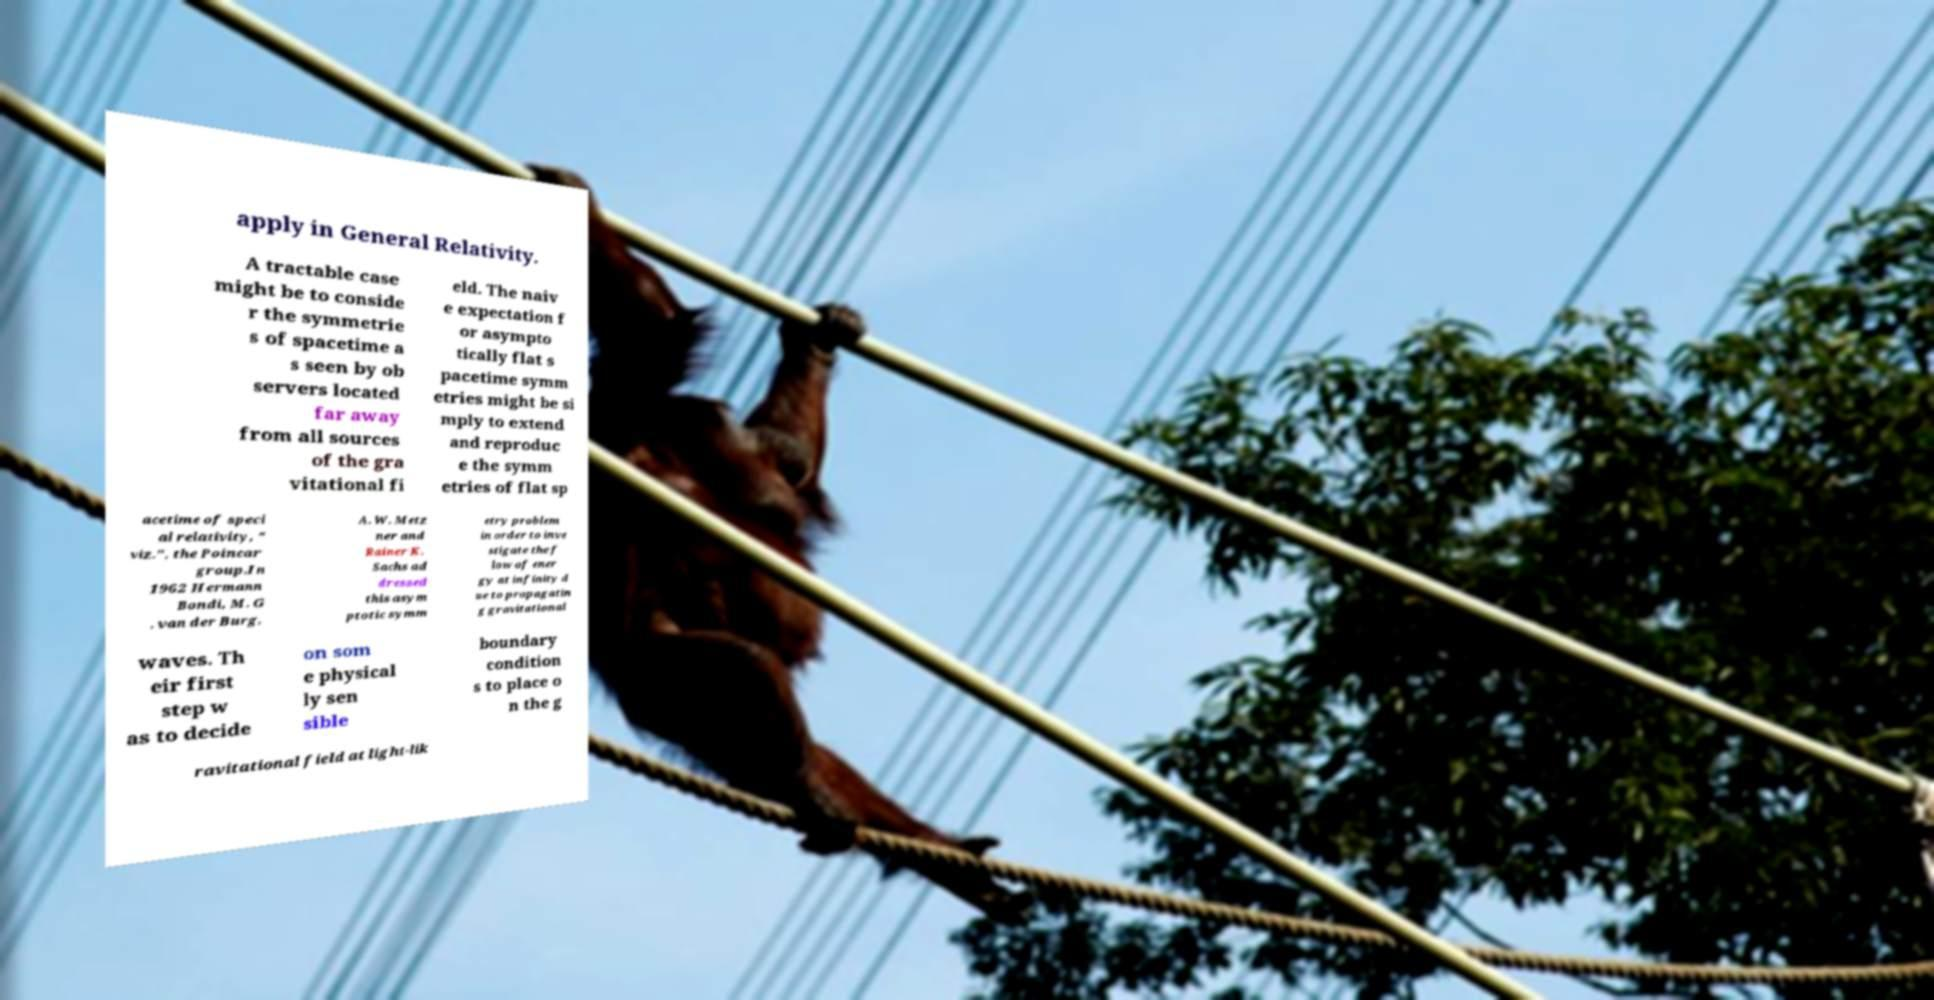What messages or text are displayed in this image? I need them in a readable, typed format. apply in General Relativity. A tractable case might be to conside r the symmetrie s of spacetime a s seen by ob servers located far away from all sources of the gra vitational fi eld. The naiv e expectation f or asympto tically flat s pacetime symm etries might be si mply to extend and reproduc e the symm etries of flat sp acetime of speci al relativity, " viz.", the Poincar group.In 1962 Hermann Bondi, M. G . van der Burg, A. W. Metz ner and Rainer K. Sachs ad dressed this asym ptotic symm etry problem in order to inve stigate the f low of ener gy at infinity d ue to propagatin g gravitational waves. Th eir first step w as to decide on som e physical ly sen sible boundary condition s to place o n the g ravitational field at light-lik 